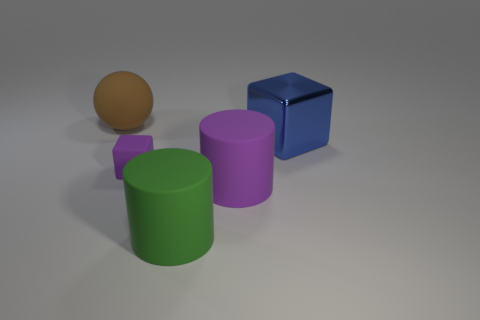How many things are large brown balls or things that are on the right side of the brown rubber object?
Your answer should be compact. 5. What material is the other object that is the same shape as the metal thing?
Provide a short and direct response. Rubber. Does the purple object that is on the right side of the green rubber cylinder have the same shape as the green matte object?
Make the answer very short. Yes. Are there any other things that have the same size as the purple block?
Give a very brief answer. No. Is the number of large blue blocks that are in front of the purple cylinder less than the number of large brown rubber spheres that are behind the blue thing?
Your response must be concise. Yes. What number of other things are the same shape as the small purple matte thing?
Offer a very short reply. 1. What size is the rubber cylinder in front of the purple object that is in front of the block that is in front of the blue metallic thing?
Offer a terse response. Large. What number of cyan objects are either tiny things or rubber balls?
Your response must be concise. 0. What shape is the purple object that is on the right side of the cube in front of the big blue metal object?
Offer a very short reply. Cylinder. Do the purple thing on the left side of the big purple thing and the block that is right of the matte block have the same size?
Provide a succinct answer. No. 